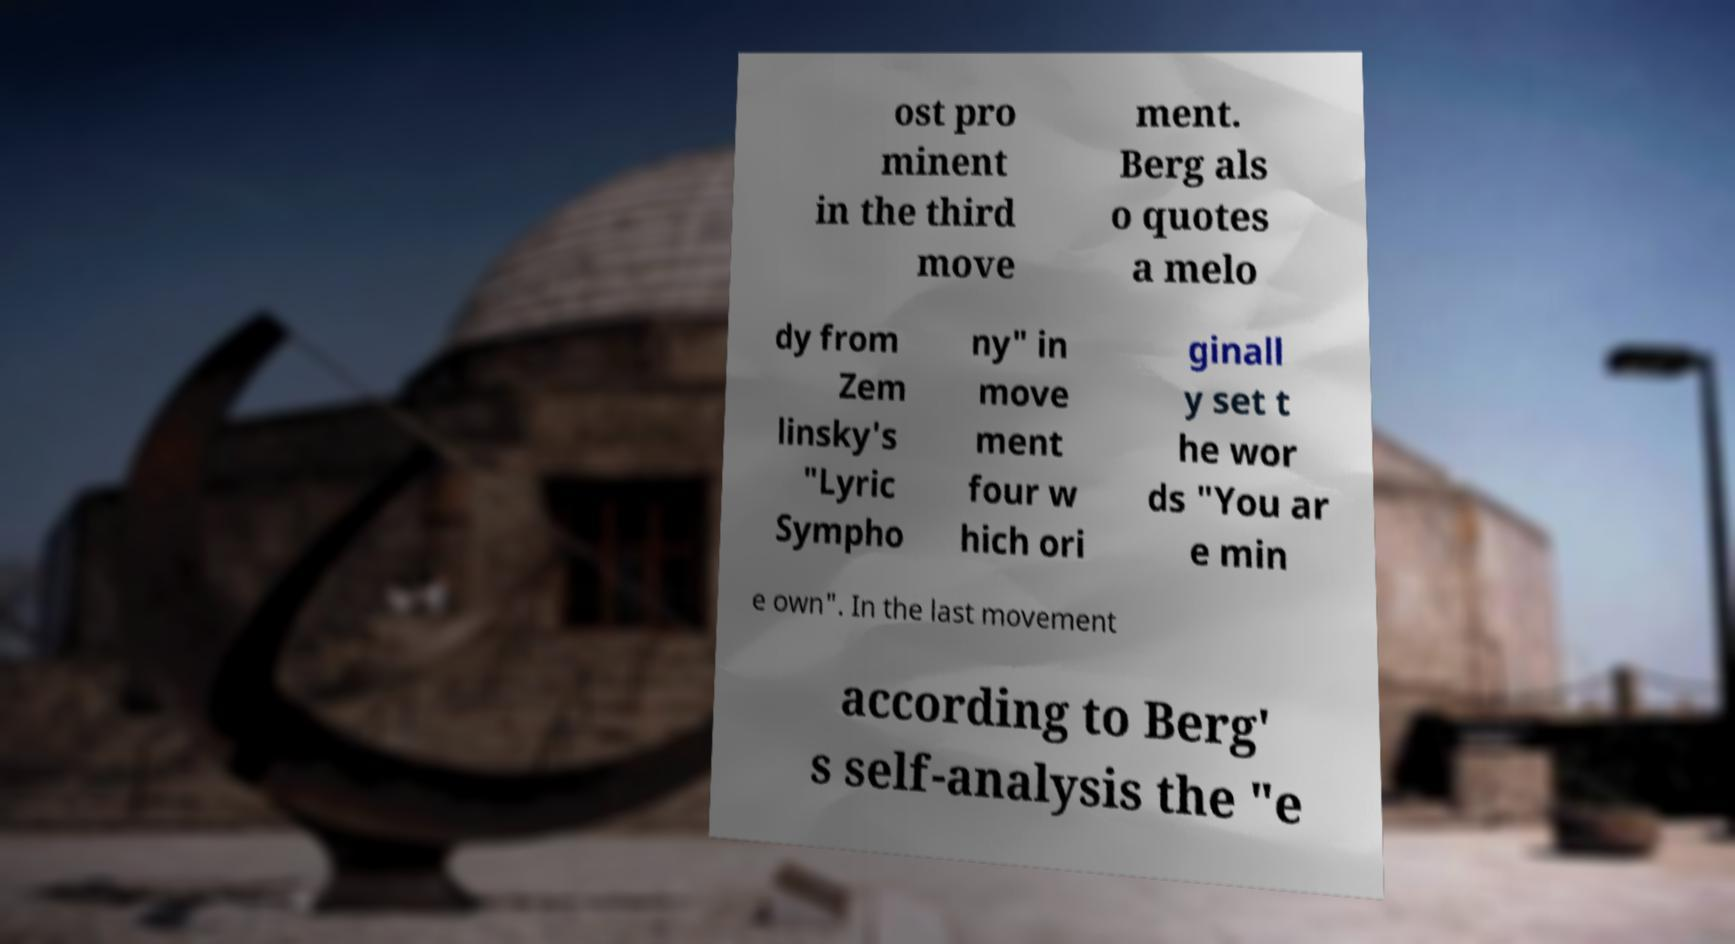Can you accurately transcribe the text from the provided image for me? ost pro minent in the third move ment. Berg als o quotes a melo dy from Zem linsky's "Lyric Sympho ny" in move ment four w hich ori ginall y set t he wor ds "You ar e min e own". In the last movement according to Berg' s self-analysis the "e 